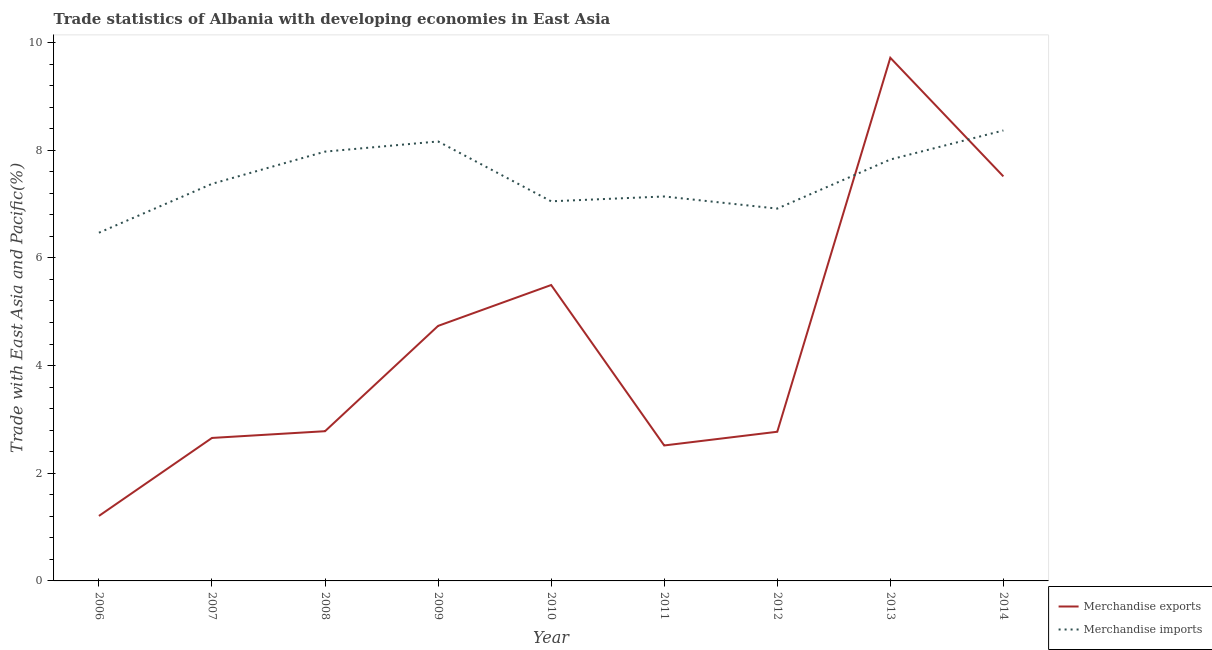Is the number of lines equal to the number of legend labels?
Provide a short and direct response. Yes. What is the merchandise exports in 2011?
Offer a very short reply. 2.52. Across all years, what is the maximum merchandise exports?
Provide a short and direct response. 9.72. Across all years, what is the minimum merchandise exports?
Offer a very short reply. 1.21. In which year was the merchandise exports minimum?
Give a very brief answer. 2006. What is the total merchandise imports in the graph?
Give a very brief answer. 67.28. What is the difference between the merchandise exports in 2011 and that in 2014?
Provide a short and direct response. -5. What is the difference between the merchandise exports in 2006 and the merchandise imports in 2009?
Keep it short and to the point. -6.96. What is the average merchandise exports per year?
Offer a very short reply. 4.38. In the year 2010, what is the difference between the merchandise exports and merchandise imports?
Your response must be concise. -1.56. In how many years, is the merchandise exports greater than 2.4 %?
Offer a terse response. 8. What is the ratio of the merchandise exports in 2010 to that in 2014?
Your answer should be compact. 0.73. Is the merchandise imports in 2010 less than that in 2014?
Offer a terse response. Yes. Is the difference between the merchandise imports in 2010 and 2011 greater than the difference between the merchandise exports in 2010 and 2011?
Your response must be concise. No. What is the difference between the highest and the second highest merchandise imports?
Give a very brief answer. 0.2. What is the difference between the highest and the lowest merchandise imports?
Make the answer very short. 1.9. Is the sum of the merchandise imports in 2007 and 2010 greater than the maximum merchandise exports across all years?
Keep it short and to the point. Yes. Does the merchandise exports monotonically increase over the years?
Make the answer very short. No. How many lines are there?
Your response must be concise. 2. What is the difference between two consecutive major ticks on the Y-axis?
Offer a very short reply. 2. Are the values on the major ticks of Y-axis written in scientific E-notation?
Provide a succinct answer. No. Does the graph contain any zero values?
Provide a short and direct response. No. Does the graph contain grids?
Offer a terse response. No. Where does the legend appear in the graph?
Offer a terse response. Bottom right. How are the legend labels stacked?
Your response must be concise. Vertical. What is the title of the graph?
Your answer should be compact. Trade statistics of Albania with developing economies in East Asia. What is the label or title of the Y-axis?
Make the answer very short. Trade with East Asia and Pacific(%). What is the Trade with East Asia and Pacific(%) of Merchandise exports in 2006?
Offer a terse response. 1.21. What is the Trade with East Asia and Pacific(%) in Merchandise imports in 2006?
Keep it short and to the point. 6.47. What is the Trade with East Asia and Pacific(%) of Merchandise exports in 2007?
Ensure brevity in your answer.  2.66. What is the Trade with East Asia and Pacific(%) of Merchandise imports in 2007?
Offer a terse response. 7.38. What is the Trade with East Asia and Pacific(%) of Merchandise exports in 2008?
Your answer should be very brief. 2.78. What is the Trade with East Asia and Pacific(%) in Merchandise imports in 2008?
Your answer should be compact. 7.97. What is the Trade with East Asia and Pacific(%) of Merchandise exports in 2009?
Offer a very short reply. 4.74. What is the Trade with East Asia and Pacific(%) of Merchandise imports in 2009?
Ensure brevity in your answer.  8.16. What is the Trade with East Asia and Pacific(%) in Merchandise exports in 2010?
Offer a very short reply. 5.5. What is the Trade with East Asia and Pacific(%) in Merchandise imports in 2010?
Keep it short and to the point. 7.05. What is the Trade with East Asia and Pacific(%) in Merchandise exports in 2011?
Make the answer very short. 2.52. What is the Trade with East Asia and Pacific(%) of Merchandise imports in 2011?
Give a very brief answer. 7.14. What is the Trade with East Asia and Pacific(%) of Merchandise exports in 2012?
Keep it short and to the point. 2.77. What is the Trade with East Asia and Pacific(%) in Merchandise imports in 2012?
Offer a very short reply. 6.92. What is the Trade with East Asia and Pacific(%) of Merchandise exports in 2013?
Your answer should be compact. 9.72. What is the Trade with East Asia and Pacific(%) of Merchandise imports in 2013?
Your response must be concise. 7.83. What is the Trade with East Asia and Pacific(%) in Merchandise exports in 2014?
Ensure brevity in your answer.  7.51. What is the Trade with East Asia and Pacific(%) of Merchandise imports in 2014?
Give a very brief answer. 8.37. Across all years, what is the maximum Trade with East Asia and Pacific(%) in Merchandise exports?
Make the answer very short. 9.72. Across all years, what is the maximum Trade with East Asia and Pacific(%) in Merchandise imports?
Offer a terse response. 8.37. Across all years, what is the minimum Trade with East Asia and Pacific(%) in Merchandise exports?
Ensure brevity in your answer.  1.21. Across all years, what is the minimum Trade with East Asia and Pacific(%) of Merchandise imports?
Your answer should be very brief. 6.47. What is the total Trade with East Asia and Pacific(%) in Merchandise exports in the graph?
Make the answer very short. 39.39. What is the total Trade with East Asia and Pacific(%) in Merchandise imports in the graph?
Provide a succinct answer. 67.28. What is the difference between the Trade with East Asia and Pacific(%) of Merchandise exports in 2006 and that in 2007?
Make the answer very short. -1.45. What is the difference between the Trade with East Asia and Pacific(%) in Merchandise imports in 2006 and that in 2007?
Make the answer very short. -0.91. What is the difference between the Trade with East Asia and Pacific(%) of Merchandise exports in 2006 and that in 2008?
Give a very brief answer. -1.57. What is the difference between the Trade with East Asia and Pacific(%) of Merchandise imports in 2006 and that in 2008?
Make the answer very short. -1.51. What is the difference between the Trade with East Asia and Pacific(%) of Merchandise exports in 2006 and that in 2009?
Offer a terse response. -3.53. What is the difference between the Trade with East Asia and Pacific(%) in Merchandise imports in 2006 and that in 2009?
Provide a succinct answer. -1.7. What is the difference between the Trade with East Asia and Pacific(%) of Merchandise exports in 2006 and that in 2010?
Ensure brevity in your answer.  -4.29. What is the difference between the Trade with East Asia and Pacific(%) of Merchandise imports in 2006 and that in 2010?
Ensure brevity in your answer.  -0.58. What is the difference between the Trade with East Asia and Pacific(%) of Merchandise exports in 2006 and that in 2011?
Keep it short and to the point. -1.31. What is the difference between the Trade with East Asia and Pacific(%) in Merchandise imports in 2006 and that in 2011?
Give a very brief answer. -0.67. What is the difference between the Trade with East Asia and Pacific(%) of Merchandise exports in 2006 and that in 2012?
Keep it short and to the point. -1.56. What is the difference between the Trade with East Asia and Pacific(%) in Merchandise imports in 2006 and that in 2012?
Keep it short and to the point. -0.45. What is the difference between the Trade with East Asia and Pacific(%) in Merchandise exports in 2006 and that in 2013?
Provide a short and direct response. -8.51. What is the difference between the Trade with East Asia and Pacific(%) of Merchandise imports in 2006 and that in 2013?
Give a very brief answer. -1.36. What is the difference between the Trade with East Asia and Pacific(%) of Merchandise exports in 2006 and that in 2014?
Ensure brevity in your answer.  -6.31. What is the difference between the Trade with East Asia and Pacific(%) in Merchandise imports in 2006 and that in 2014?
Your answer should be very brief. -1.9. What is the difference between the Trade with East Asia and Pacific(%) in Merchandise exports in 2007 and that in 2008?
Your answer should be very brief. -0.12. What is the difference between the Trade with East Asia and Pacific(%) of Merchandise imports in 2007 and that in 2008?
Your answer should be very brief. -0.6. What is the difference between the Trade with East Asia and Pacific(%) in Merchandise exports in 2007 and that in 2009?
Make the answer very short. -2.08. What is the difference between the Trade with East Asia and Pacific(%) of Merchandise imports in 2007 and that in 2009?
Your response must be concise. -0.79. What is the difference between the Trade with East Asia and Pacific(%) of Merchandise exports in 2007 and that in 2010?
Your answer should be very brief. -2.84. What is the difference between the Trade with East Asia and Pacific(%) of Merchandise imports in 2007 and that in 2010?
Make the answer very short. 0.32. What is the difference between the Trade with East Asia and Pacific(%) in Merchandise exports in 2007 and that in 2011?
Give a very brief answer. 0.14. What is the difference between the Trade with East Asia and Pacific(%) in Merchandise imports in 2007 and that in 2011?
Provide a succinct answer. 0.23. What is the difference between the Trade with East Asia and Pacific(%) in Merchandise exports in 2007 and that in 2012?
Ensure brevity in your answer.  -0.11. What is the difference between the Trade with East Asia and Pacific(%) in Merchandise imports in 2007 and that in 2012?
Give a very brief answer. 0.46. What is the difference between the Trade with East Asia and Pacific(%) in Merchandise exports in 2007 and that in 2013?
Make the answer very short. -7.06. What is the difference between the Trade with East Asia and Pacific(%) in Merchandise imports in 2007 and that in 2013?
Your answer should be very brief. -0.45. What is the difference between the Trade with East Asia and Pacific(%) in Merchandise exports in 2007 and that in 2014?
Offer a very short reply. -4.86. What is the difference between the Trade with East Asia and Pacific(%) of Merchandise imports in 2007 and that in 2014?
Offer a terse response. -0.99. What is the difference between the Trade with East Asia and Pacific(%) in Merchandise exports in 2008 and that in 2009?
Your answer should be very brief. -1.96. What is the difference between the Trade with East Asia and Pacific(%) of Merchandise imports in 2008 and that in 2009?
Offer a terse response. -0.19. What is the difference between the Trade with East Asia and Pacific(%) of Merchandise exports in 2008 and that in 2010?
Ensure brevity in your answer.  -2.72. What is the difference between the Trade with East Asia and Pacific(%) in Merchandise imports in 2008 and that in 2010?
Offer a terse response. 0.92. What is the difference between the Trade with East Asia and Pacific(%) in Merchandise exports in 2008 and that in 2011?
Your response must be concise. 0.26. What is the difference between the Trade with East Asia and Pacific(%) of Merchandise imports in 2008 and that in 2011?
Your answer should be very brief. 0.83. What is the difference between the Trade with East Asia and Pacific(%) in Merchandise exports in 2008 and that in 2012?
Your answer should be compact. 0.01. What is the difference between the Trade with East Asia and Pacific(%) in Merchandise imports in 2008 and that in 2012?
Provide a short and direct response. 1.06. What is the difference between the Trade with East Asia and Pacific(%) of Merchandise exports in 2008 and that in 2013?
Ensure brevity in your answer.  -6.94. What is the difference between the Trade with East Asia and Pacific(%) in Merchandise imports in 2008 and that in 2013?
Make the answer very short. 0.15. What is the difference between the Trade with East Asia and Pacific(%) of Merchandise exports in 2008 and that in 2014?
Your answer should be very brief. -4.73. What is the difference between the Trade with East Asia and Pacific(%) of Merchandise imports in 2008 and that in 2014?
Your answer should be very brief. -0.39. What is the difference between the Trade with East Asia and Pacific(%) of Merchandise exports in 2009 and that in 2010?
Provide a short and direct response. -0.76. What is the difference between the Trade with East Asia and Pacific(%) in Merchandise imports in 2009 and that in 2010?
Ensure brevity in your answer.  1.11. What is the difference between the Trade with East Asia and Pacific(%) of Merchandise exports in 2009 and that in 2011?
Offer a very short reply. 2.22. What is the difference between the Trade with East Asia and Pacific(%) in Merchandise imports in 2009 and that in 2011?
Make the answer very short. 1.02. What is the difference between the Trade with East Asia and Pacific(%) in Merchandise exports in 2009 and that in 2012?
Ensure brevity in your answer.  1.97. What is the difference between the Trade with East Asia and Pacific(%) of Merchandise imports in 2009 and that in 2012?
Give a very brief answer. 1.25. What is the difference between the Trade with East Asia and Pacific(%) in Merchandise exports in 2009 and that in 2013?
Ensure brevity in your answer.  -4.98. What is the difference between the Trade with East Asia and Pacific(%) of Merchandise imports in 2009 and that in 2013?
Keep it short and to the point. 0.34. What is the difference between the Trade with East Asia and Pacific(%) in Merchandise exports in 2009 and that in 2014?
Make the answer very short. -2.78. What is the difference between the Trade with East Asia and Pacific(%) of Merchandise imports in 2009 and that in 2014?
Your answer should be very brief. -0.2. What is the difference between the Trade with East Asia and Pacific(%) in Merchandise exports in 2010 and that in 2011?
Give a very brief answer. 2.98. What is the difference between the Trade with East Asia and Pacific(%) in Merchandise imports in 2010 and that in 2011?
Your answer should be compact. -0.09. What is the difference between the Trade with East Asia and Pacific(%) in Merchandise exports in 2010 and that in 2012?
Your response must be concise. 2.73. What is the difference between the Trade with East Asia and Pacific(%) in Merchandise imports in 2010 and that in 2012?
Provide a succinct answer. 0.14. What is the difference between the Trade with East Asia and Pacific(%) in Merchandise exports in 2010 and that in 2013?
Offer a terse response. -4.22. What is the difference between the Trade with East Asia and Pacific(%) in Merchandise imports in 2010 and that in 2013?
Make the answer very short. -0.78. What is the difference between the Trade with East Asia and Pacific(%) in Merchandise exports in 2010 and that in 2014?
Your answer should be very brief. -2.02. What is the difference between the Trade with East Asia and Pacific(%) in Merchandise imports in 2010 and that in 2014?
Provide a succinct answer. -1.32. What is the difference between the Trade with East Asia and Pacific(%) in Merchandise exports in 2011 and that in 2012?
Give a very brief answer. -0.25. What is the difference between the Trade with East Asia and Pacific(%) in Merchandise imports in 2011 and that in 2012?
Provide a succinct answer. 0.23. What is the difference between the Trade with East Asia and Pacific(%) in Merchandise exports in 2011 and that in 2013?
Your response must be concise. -7.2. What is the difference between the Trade with East Asia and Pacific(%) in Merchandise imports in 2011 and that in 2013?
Make the answer very short. -0.69. What is the difference between the Trade with East Asia and Pacific(%) of Merchandise exports in 2011 and that in 2014?
Give a very brief answer. -5. What is the difference between the Trade with East Asia and Pacific(%) in Merchandise imports in 2011 and that in 2014?
Your response must be concise. -1.23. What is the difference between the Trade with East Asia and Pacific(%) of Merchandise exports in 2012 and that in 2013?
Your answer should be compact. -6.95. What is the difference between the Trade with East Asia and Pacific(%) of Merchandise imports in 2012 and that in 2013?
Keep it short and to the point. -0.91. What is the difference between the Trade with East Asia and Pacific(%) in Merchandise exports in 2012 and that in 2014?
Provide a short and direct response. -4.74. What is the difference between the Trade with East Asia and Pacific(%) in Merchandise imports in 2012 and that in 2014?
Ensure brevity in your answer.  -1.45. What is the difference between the Trade with East Asia and Pacific(%) of Merchandise exports in 2013 and that in 2014?
Your answer should be very brief. 2.2. What is the difference between the Trade with East Asia and Pacific(%) in Merchandise imports in 2013 and that in 2014?
Keep it short and to the point. -0.54. What is the difference between the Trade with East Asia and Pacific(%) in Merchandise exports in 2006 and the Trade with East Asia and Pacific(%) in Merchandise imports in 2007?
Give a very brief answer. -6.17. What is the difference between the Trade with East Asia and Pacific(%) in Merchandise exports in 2006 and the Trade with East Asia and Pacific(%) in Merchandise imports in 2008?
Provide a short and direct response. -6.77. What is the difference between the Trade with East Asia and Pacific(%) in Merchandise exports in 2006 and the Trade with East Asia and Pacific(%) in Merchandise imports in 2009?
Provide a succinct answer. -6.96. What is the difference between the Trade with East Asia and Pacific(%) in Merchandise exports in 2006 and the Trade with East Asia and Pacific(%) in Merchandise imports in 2010?
Provide a short and direct response. -5.84. What is the difference between the Trade with East Asia and Pacific(%) in Merchandise exports in 2006 and the Trade with East Asia and Pacific(%) in Merchandise imports in 2011?
Your answer should be very brief. -5.93. What is the difference between the Trade with East Asia and Pacific(%) in Merchandise exports in 2006 and the Trade with East Asia and Pacific(%) in Merchandise imports in 2012?
Provide a succinct answer. -5.71. What is the difference between the Trade with East Asia and Pacific(%) in Merchandise exports in 2006 and the Trade with East Asia and Pacific(%) in Merchandise imports in 2013?
Ensure brevity in your answer.  -6.62. What is the difference between the Trade with East Asia and Pacific(%) in Merchandise exports in 2006 and the Trade with East Asia and Pacific(%) in Merchandise imports in 2014?
Offer a terse response. -7.16. What is the difference between the Trade with East Asia and Pacific(%) of Merchandise exports in 2007 and the Trade with East Asia and Pacific(%) of Merchandise imports in 2008?
Keep it short and to the point. -5.32. What is the difference between the Trade with East Asia and Pacific(%) of Merchandise exports in 2007 and the Trade with East Asia and Pacific(%) of Merchandise imports in 2009?
Keep it short and to the point. -5.51. What is the difference between the Trade with East Asia and Pacific(%) of Merchandise exports in 2007 and the Trade with East Asia and Pacific(%) of Merchandise imports in 2010?
Your response must be concise. -4.4. What is the difference between the Trade with East Asia and Pacific(%) in Merchandise exports in 2007 and the Trade with East Asia and Pacific(%) in Merchandise imports in 2011?
Your response must be concise. -4.48. What is the difference between the Trade with East Asia and Pacific(%) of Merchandise exports in 2007 and the Trade with East Asia and Pacific(%) of Merchandise imports in 2012?
Provide a succinct answer. -4.26. What is the difference between the Trade with East Asia and Pacific(%) in Merchandise exports in 2007 and the Trade with East Asia and Pacific(%) in Merchandise imports in 2013?
Ensure brevity in your answer.  -5.17. What is the difference between the Trade with East Asia and Pacific(%) in Merchandise exports in 2007 and the Trade with East Asia and Pacific(%) in Merchandise imports in 2014?
Make the answer very short. -5.71. What is the difference between the Trade with East Asia and Pacific(%) of Merchandise exports in 2008 and the Trade with East Asia and Pacific(%) of Merchandise imports in 2009?
Give a very brief answer. -5.38. What is the difference between the Trade with East Asia and Pacific(%) in Merchandise exports in 2008 and the Trade with East Asia and Pacific(%) in Merchandise imports in 2010?
Make the answer very short. -4.27. What is the difference between the Trade with East Asia and Pacific(%) in Merchandise exports in 2008 and the Trade with East Asia and Pacific(%) in Merchandise imports in 2011?
Keep it short and to the point. -4.36. What is the difference between the Trade with East Asia and Pacific(%) of Merchandise exports in 2008 and the Trade with East Asia and Pacific(%) of Merchandise imports in 2012?
Your answer should be very brief. -4.13. What is the difference between the Trade with East Asia and Pacific(%) of Merchandise exports in 2008 and the Trade with East Asia and Pacific(%) of Merchandise imports in 2013?
Give a very brief answer. -5.05. What is the difference between the Trade with East Asia and Pacific(%) of Merchandise exports in 2008 and the Trade with East Asia and Pacific(%) of Merchandise imports in 2014?
Offer a terse response. -5.59. What is the difference between the Trade with East Asia and Pacific(%) in Merchandise exports in 2009 and the Trade with East Asia and Pacific(%) in Merchandise imports in 2010?
Give a very brief answer. -2.31. What is the difference between the Trade with East Asia and Pacific(%) of Merchandise exports in 2009 and the Trade with East Asia and Pacific(%) of Merchandise imports in 2011?
Your answer should be very brief. -2.4. What is the difference between the Trade with East Asia and Pacific(%) in Merchandise exports in 2009 and the Trade with East Asia and Pacific(%) in Merchandise imports in 2012?
Keep it short and to the point. -2.18. What is the difference between the Trade with East Asia and Pacific(%) in Merchandise exports in 2009 and the Trade with East Asia and Pacific(%) in Merchandise imports in 2013?
Offer a terse response. -3.09. What is the difference between the Trade with East Asia and Pacific(%) of Merchandise exports in 2009 and the Trade with East Asia and Pacific(%) of Merchandise imports in 2014?
Make the answer very short. -3.63. What is the difference between the Trade with East Asia and Pacific(%) in Merchandise exports in 2010 and the Trade with East Asia and Pacific(%) in Merchandise imports in 2011?
Offer a terse response. -1.64. What is the difference between the Trade with East Asia and Pacific(%) in Merchandise exports in 2010 and the Trade with East Asia and Pacific(%) in Merchandise imports in 2012?
Keep it short and to the point. -1.42. What is the difference between the Trade with East Asia and Pacific(%) of Merchandise exports in 2010 and the Trade with East Asia and Pacific(%) of Merchandise imports in 2013?
Provide a short and direct response. -2.33. What is the difference between the Trade with East Asia and Pacific(%) of Merchandise exports in 2010 and the Trade with East Asia and Pacific(%) of Merchandise imports in 2014?
Offer a very short reply. -2.87. What is the difference between the Trade with East Asia and Pacific(%) of Merchandise exports in 2011 and the Trade with East Asia and Pacific(%) of Merchandise imports in 2012?
Offer a very short reply. -4.4. What is the difference between the Trade with East Asia and Pacific(%) in Merchandise exports in 2011 and the Trade with East Asia and Pacific(%) in Merchandise imports in 2013?
Offer a very short reply. -5.31. What is the difference between the Trade with East Asia and Pacific(%) in Merchandise exports in 2011 and the Trade with East Asia and Pacific(%) in Merchandise imports in 2014?
Offer a very short reply. -5.85. What is the difference between the Trade with East Asia and Pacific(%) in Merchandise exports in 2012 and the Trade with East Asia and Pacific(%) in Merchandise imports in 2013?
Keep it short and to the point. -5.06. What is the difference between the Trade with East Asia and Pacific(%) of Merchandise exports in 2012 and the Trade with East Asia and Pacific(%) of Merchandise imports in 2014?
Your answer should be compact. -5.6. What is the difference between the Trade with East Asia and Pacific(%) in Merchandise exports in 2013 and the Trade with East Asia and Pacific(%) in Merchandise imports in 2014?
Your answer should be compact. 1.35. What is the average Trade with East Asia and Pacific(%) in Merchandise exports per year?
Offer a terse response. 4.38. What is the average Trade with East Asia and Pacific(%) of Merchandise imports per year?
Give a very brief answer. 7.48. In the year 2006, what is the difference between the Trade with East Asia and Pacific(%) in Merchandise exports and Trade with East Asia and Pacific(%) in Merchandise imports?
Give a very brief answer. -5.26. In the year 2007, what is the difference between the Trade with East Asia and Pacific(%) of Merchandise exports and Trade with East Asia and Pacific(%) of Merchandise imports?
Ensure brevity in your answer.  -4.72. In the year 2008, what is the difference between the Trade with East Asia and Pacific(%) in Merchandise exports and Trade with East Asia and Pacific(%) in Merchandise imports?
Your response must be concise. -5.19. In the year 2009, what is the difference between the Trade with East Asia and Pacific(%) in Merchandise exports and Trade with East Asia and Pacific(%) in Merchandise imports?
Provide a succinct answer. -3.43. In the year 2010, what is the difference between the Trade with East Asia and Pacific(%) of Merchandise exports and Trade with East Asia and Pacific(%) of Merchandise imports?
Offer a very short reply. -1.55. In the year 2011, what is the difference between the Trade with East Asia and Pacific(%) in Merchandise exports and Trade with East Asia and Pacific(%) in Merchandise imports?
Offer a terse response. -4.62. In the year 2012, what is the difference between the Trade with East Asia and Pacific(%) in Merchandise exports and Trade with East Asia and Pacific(%) in Merchandise imports?
Your answer should be very brief. -4.14. In the year 2013, what is the difference between the Trade with East Asia and Pacific(%) in Merchandise exports and Trade with East Asia and Pacific(%) in Merchandise imports?
Provide a succinct answer. 1.89. In the year 2014, what is the difference between the Trade with East Asia and Pacific(%) of Merchandise exports and Trade with East Asia and Pacific(%) of Merchandise imports?
Ensure brevity in your answer.  -0.85. What is the ratio of the Trade with East Asia and Pacific(%) in Merchandise exports in 2006 to that in 2007?
Your answer should be very brief. 0.45. What is the ratio of the Trade with East Asia and Pacific(%) of Merchandise imports in 2006 to that in 2007?
Give a very brief answer. 0.88. What is the ratio of the Trade with East Asia and Pacific(%) of Merchandise exports in 2006 to that in 2008?
Provide a succinct answer. 0.43. What is the ratio of the Trade with East Asia and Pacific(%) of Merchandise imports in 2006 to that in 2008?
Your response must be concise. 0.81. What is the ratio of the Trade with East Asia and Pacific(%) in Merchandise exports in 2006 to that in 2009?
Provide a succinct answer. 0.25. What is the ratio of the Trade with East Asia and Pacific(%) in Merchandise imports in 2006 to that in 2009?
Your response must be concise. 0.79. What is the ratio of the Trade with East Asia and Pacific(%) of Merchandise exports in 2006 to that in 2010?
Provide a succinct answer. 0.22. What is the ratio of the Trade with East Asia and Pacific(%) in Merchandise imports in 2006 to that in 2010?
Offer a very short reply. 0.92. What is the ratio of the Trade with East Asia and Pacific(%) in Merchandise exports in 2006 to that in 2011?
Provide a succinct answer. 0.48. What is the ratio of the Trade with East Asia and Pacific(%) in Merchandise imports in 2006 to that in 2011?
Keep it short and to the point. 0.91. What is the ratio of the Trade with East Asia and Pacific(%) in Merchandise exports in 2006 to that in 2012?
Provide a succinct answer. 0.44. What is the ratio of the Trade with East Asia and Pacific(%) of Merchandise imports in 2006 to that in 2012?
Your answer should be compact. 0.94. What is the ratio of the Trade with East Asia and Pacific(%) of Merchandise exports in 2006 to that in 2013?
Offer a terse response. 0.12. What is the ratio of the Trade with East Asia and Pacific(%) of Merchandise imports in 2006 to that in 2013?
Give a very brief answer. 0.83. What is the ratio of the Trade with East Asia and Pacific(%) in Merchandise exports in 2006 to that in 2014?
Provide a succinct answer. 0.16. What is the ratio of the Trade with East Asia and Pacific(%) in Merchandise imports in 2006 to that in 2014?
Your answer should be very brief. 0.77. What is the ratio of the Trade with East Asia and Pacific(%) in Merchandise exports in 2007 to that in 2008?
Your answer should be very brief. 0.96. What is the ratio of the Trade with East Asia and Pacific(%) of Merchandise imports in 2007 to that in 2008?
Provide a short and direct response. 0.93. What is the ratio of the Trade with East Asia and Pacific(%) in Merchandise exports in 2007 to that in 2009?
Your answer should be very brief. 0.56. What is the ratio of the Trade with East Asia and Pacific(%) in Merchandise imports in 2007 to that in 2009?
Keep it short and to the point. 0.9. What is the ratio of the Trade with East Asia and Pacific(%) of Merchandise exports in 2007 to that in 2010?
Your answer should be compact. 0.48. What is the ratio of the Trade with East Asia and Pacific(%) of Merchandise imports in 2007 to that in 2010?
Make the answer very short. 1.05. What is the ratio of the Trade with East Asia and Pacific(%) in Merchandise exports in 2007 to that in 2011?
Your answer should be compact. 1.06. What is the ratio of the Trade with East Asia and Pacific(%) in Merchandise imports in 2007 to that in 2011?
Ensure brevity in your answer.  1.03. What is the ratio of the Trade with East Asia and Pacific(%) of Merchandise exports in 2007 to that in 2012?
Offer a very short reply. 0.96. What is the ratio of the Trade with East Asia and Pacific(%) in Merchandise imports in 2007 to that in 2012?
Give a very brief answer. 1.07. What is the ratio of the Trade with East Asia and Pacific(%) of Merchandise exports in 2007 to that in 2013?
Provide a succinct answer. 0.27. What is the ratio of the Trade with East Asia and Pacific(%) in Merchandise imports in 2007 to that in 2013?
Ensure brevity in your answer.  0.94. What is the ratio of the Trade with East Asia and Pacific(%) of Merchandise exports in 2007 to that in 2014?
Make the answer very short. 0.35. What is the ratio of the Trade with East Asia and Pacific(%) of Merchandise imports in 2007 to that in 2014?
Ensure brevity in your answer.  0.88. What is the ratio of the Trade with East Asia and Pacific(%) in Merchandise exports in 2008 to that in 2009?
Your answer should be very brief. 0.59. What is the ratio of the Trade with East Asia and Pacific(%) of Merchandise imports in 2008 to that in 2009?
Your answer should be compact. 0.98. What is the ratio of the Trade with East Asia and Pacific(%) in Merchandise exports in 2008 to that in 2010?
Offer a very short reply. 0.51. What is the ratio of the Trade with East Asia and Pacific(%) in Merchandise imports in 2008 to that in 2010?
Your response must be concise. 1.13. What is the ratio of the Trade with East Asia and Pacific(%) of Merchandise exports in 2008 to that in 2011?
Provide a succinct answer. 1.11. What is the ratio of the Trade with East Asia and Pacific(%) of Merchandise imports in 2008 to that in 2011?
Make the answer very short. 1.12. What is the ratio of the Trade with East Asia and Pacific(%) of Merchandise exports in 2008 to that in 2012?
Keep it short and to the point. 1. What is the ratio of the Trade with East Asia and Pacific(%) in Merchandise imports in 2008 to that in 2012?
Ensure brevity in your answer.  1.15. What is the ratio of the Trade with East Asia and Pacific(%) in Merchandise exports in 2008 to that in 2013?
Your answer should be very brief. 0.29. What is the ratio of the Trade with East Asia and Pacific(%) in Merchandise imports in 2008 to that in 2013?
Keep it short and to the point. 1.02. What is the ratio of the Trade with East Asia and Pacific(%) in Merchandise exports in 2008 to that in 2014?
Give a very brief answer. 0.37. What is the ratio of the Trade with East Asia and Pacific(%) in Merchandise imports in 2008 to that in 2014?
Keep it short and to the point. 0.95. What is the ratio of the Trade with East Asia and Pacific(%) in Merchandise exports in 2009 to that in 2010?
Ensure brevity in your answer.  0.86. What is the ratio of the Trade with East Asia and Pacific(%) of Merchandise imports in 2009 to that in 2010?
Offer a terse response. 1.16. What is the ratio of the Trade with East Asia and Pacific(%) of Merchandise exports in 2009 to that in 2011?
Offer a very short reply. 1.88. What is the ratio of the Trade with East Asia and Pacific(%) of Merchandise imports in 2009 to that in 2011?
Provide a short and direct response. 1.14. What is the ratio of the Trade with East Asia and Pacific(%) in Merchandise exports in 2009 to that in 2012?
Give a very brief answer. 1.71. What is the ratio of the Trade with East Asia and Pacific(%) in Merchandise imports in 2009 to that in 2012?
Provide a short and direct response. 1.18. What is the ratio of the Trade with East Asia and Pacific(%) of Merchandise exports in 2009 to that in 2013?
Offer a terse response. 0.49. What is the ratio of the Trade with East Asia and Pacific(%) of Merchandise imports in 2009 to that in 2013?
Your answer should be compact. 1.04. What is the ratio of the Trade with East Asia and Pacific(%) of Merchandise exports in 2009 to that in 2014?
Ensure brevity in your answer.  0.63. What is the ratio of the Trade with East Asia and Pacific(%) of Merchandise imports in 2009 to that in 2014?
Ensure brevity in your answer.  0.98. What is the ratio of the Trade with East Asia and Pacific(%) of Merchandise exports in 2010 to that in 2011?
Provide a short and direct response. 2.18. What is the ratio of the Trade with East Asia and Pacific(%) in Merchandise imports in 2010 to that in 2011?
Ensure brevity in your answer.  0.99. What is the ratio of the Trade with East Asia and Pacific(%) in Merchandise exports in 2010 to that in 2012?
Give a very brief answer. 1.98. What is the ratio of the Trade with East Asia and Pacific(%) in Merchandise imports in 2010 to that in 2012?
Keep it short and to the point. 1.02. What is the ratio of the Trade with East Asia and Pacific(%) of Merchandise exports in 2010 to that in 2013?
Your answer should be compact. 0.57. What is the ratio of the Trade with East Asia and Pacific(%) of Merchandise imports in 2010 to that in 2013?
Your answer should be compact. 0.9. What is the ratio of the Trade with East Asia and Pacific(%) of Merchandise exports in 2010 to that in 2014?
Offer a very short reply. 0.73. What is the ratio of the Trade with East Asia and Pacific(%) of Merchandise imports in 2010 to that in 2014?
Offer a very short reply. 0.84. What is the ratio of the Trade with East Asia and Pacific(%) in Merchandise exports in 2011 to that in 2012?
Your answer should be compact. 0.91. What is the ratio of the Trade with East Asia and Pacific(%) of Merchandise imports in 2011 to that in 2012?
Keep it short and to the point. 1.03. What is the ratio of the Trade with East Asia and Pacific(%) in Merchandise exports in 2011 to that in 2013?
Give a very brief answer. 0.26. What is the ratio of the Trade with East Asia and Pacific(%) of Merchandise imports in 2011 to that in 2013?
Provide a short and direct response. 0.91. What is the ratio of the Trade with East Asia and Pacific(%) in Merchandise exports in 2011 to that in 2014?
Your response must be concise. 0.33. What is the ratio of the Trade with East Asia and Pacific(%) of Merchandise imports in 2011 to that in 2014?
Keep it short and to the point. 0.85. What is the ratio of the Trade with East Asia and Pacific(%) in Merchandise exports in 2012 to that in 2013?
Keep it short and to the point. 0.29. What is the ratio of the Trade with East Asia and Pacific(%) of Merchandise imports in 2012 to that in 2013?
Offer a terse response. 0.88. What is the ratio of the Trade with East Asia and Pacific(%) of Merchandise exports in 2012 to that in 2014?
Your response must be concise. 0.37. What is the ratio of the Trade with East Asia and Pacific(%) of Merchandise imports in 2012 to that in 2014?
Offer a very short reply. 0.83. What is the ratio of the Trade with East Asia and Pacific(%) in Merchandise exports in 2013 to that in 2014?
Ensure brevity in your answer.  1.29. What is the ratio of the Trade with East Asia and Pacific(%) in Merchandise imports in 2013 to that in 2014?
Offer a terse response. 0.94. What is the difference between the highest and the second highest Trade with East Asia and Pacific(%) in Merchandise exports?
Offer a terse response. 2.2. What is the difference between the highest and the second highest Trade with East Asia and Pacific(%) of Merchandise imports?
Your answer should be compact. 0.2. What is the difference between the highest and the lowest Trade with East Asia and Pacific(%) in Merchandise exports?
Make the answer very short. 8.51. What is the difference between the highest and the lowest Trade with East Asia and Pacific(%) in Merchandise imports?
Offer a terse response. 1.9. 